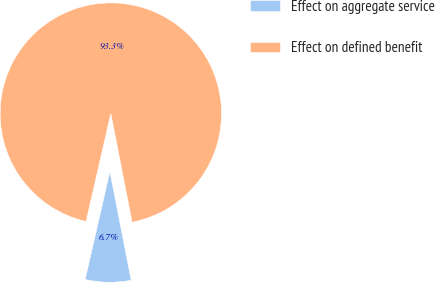<chart> <loc_0><loc_0><loc_500><loc_500><pie_chart><fcel>Effect on aggregate service<fcel>Effect on defined benefit<nl><fcel>6.67%<fcel>93.33%<nl></chart> 